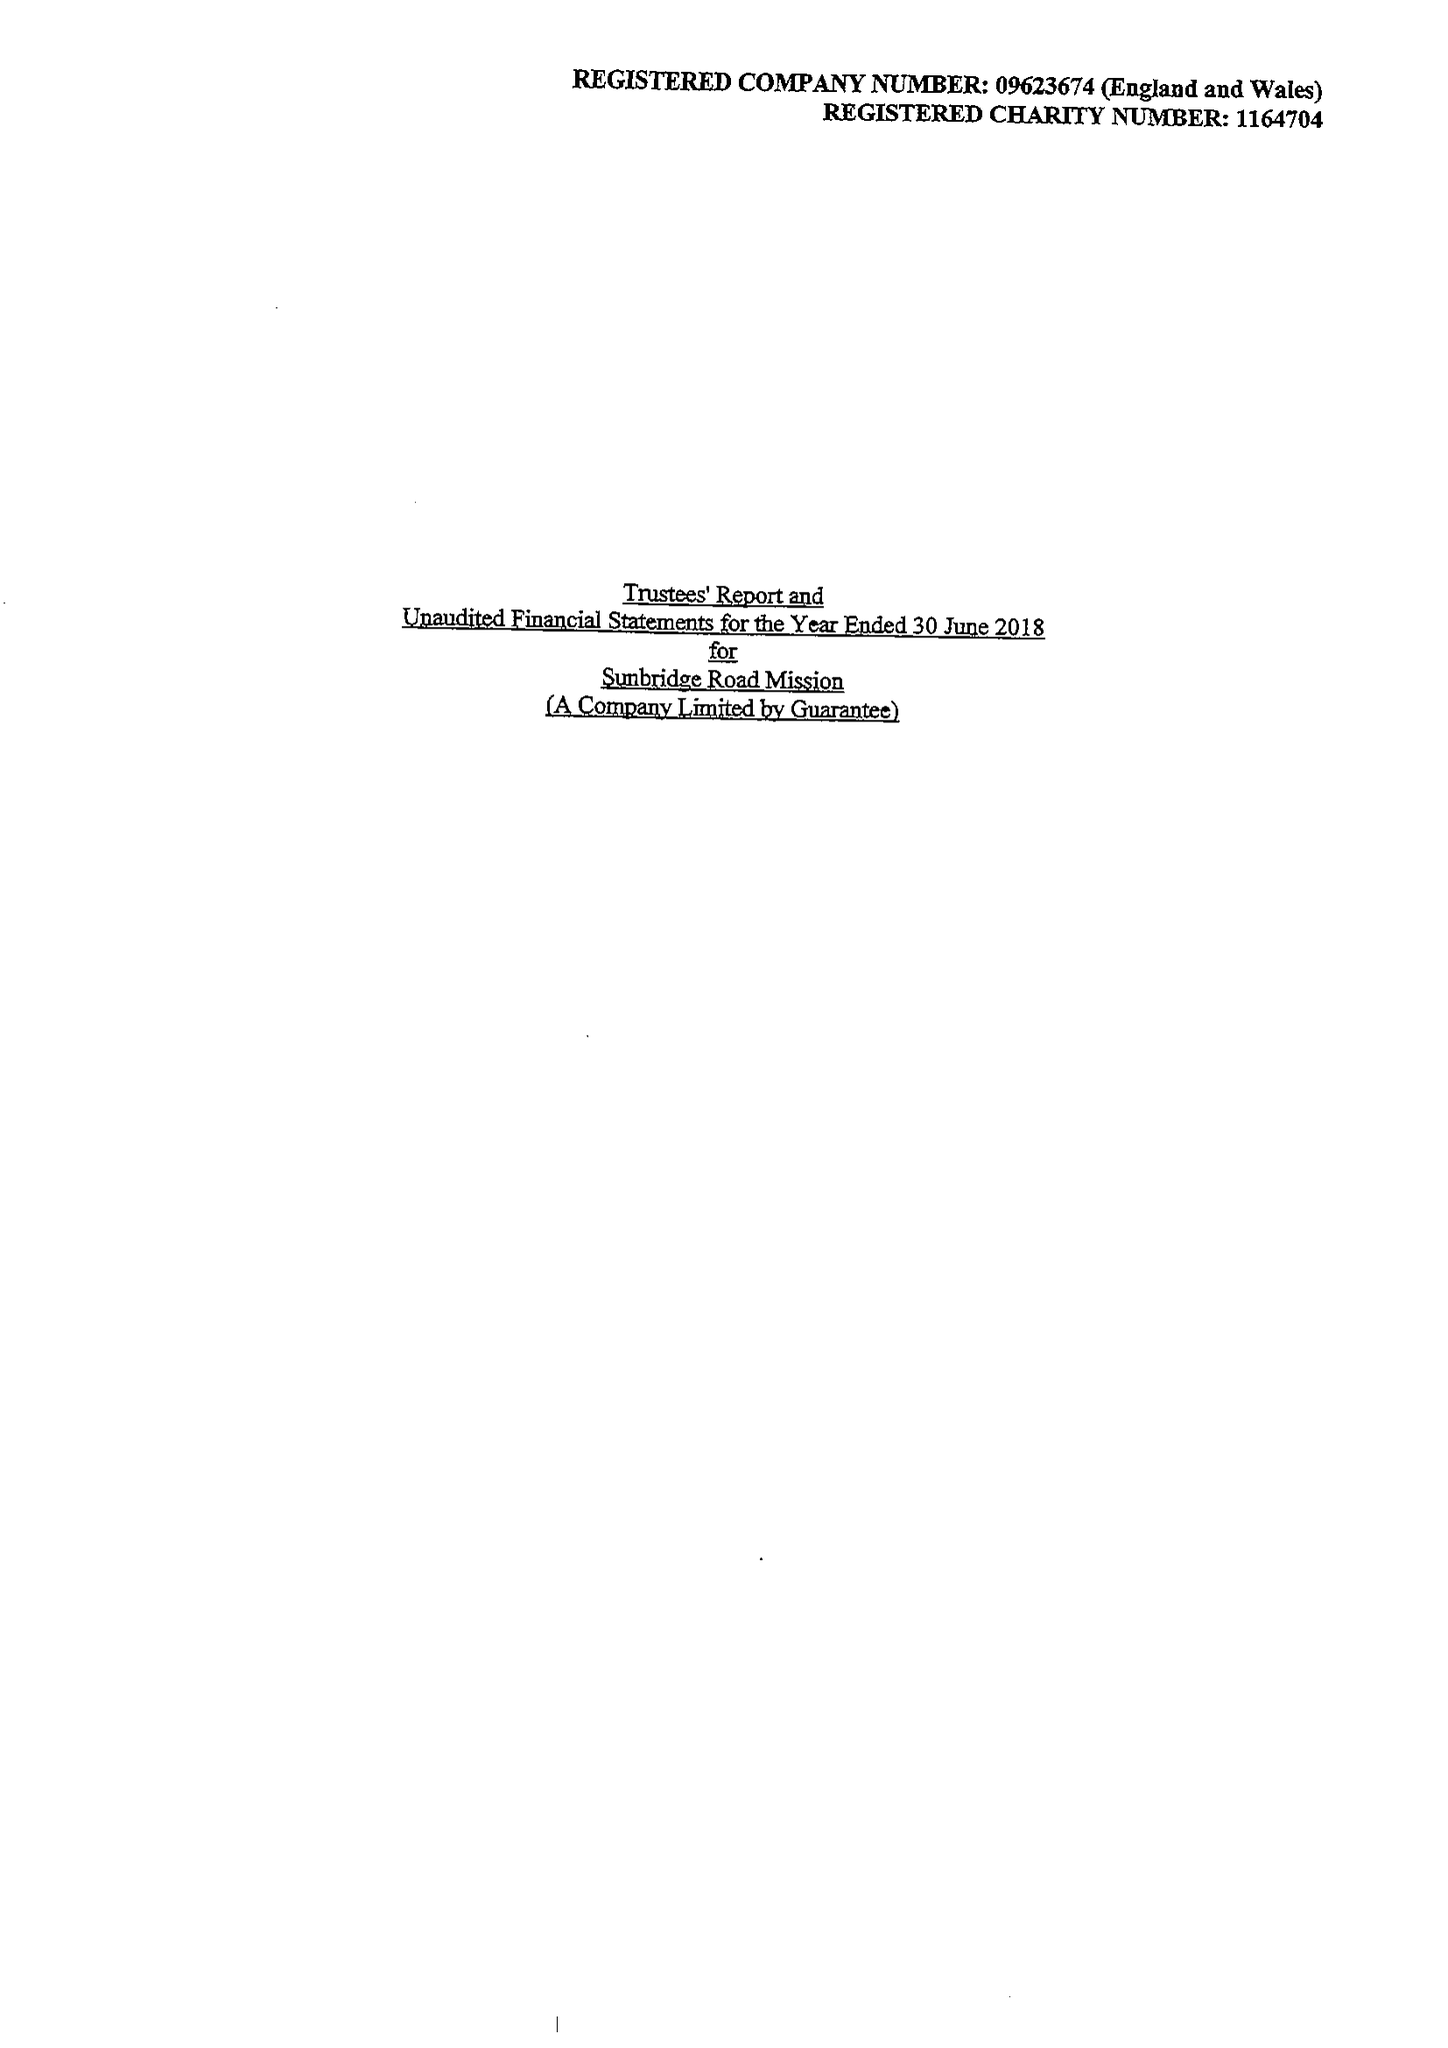What is the value for the address__postcode?
Answer the question using a single word or phrase. BD15 9JZ 